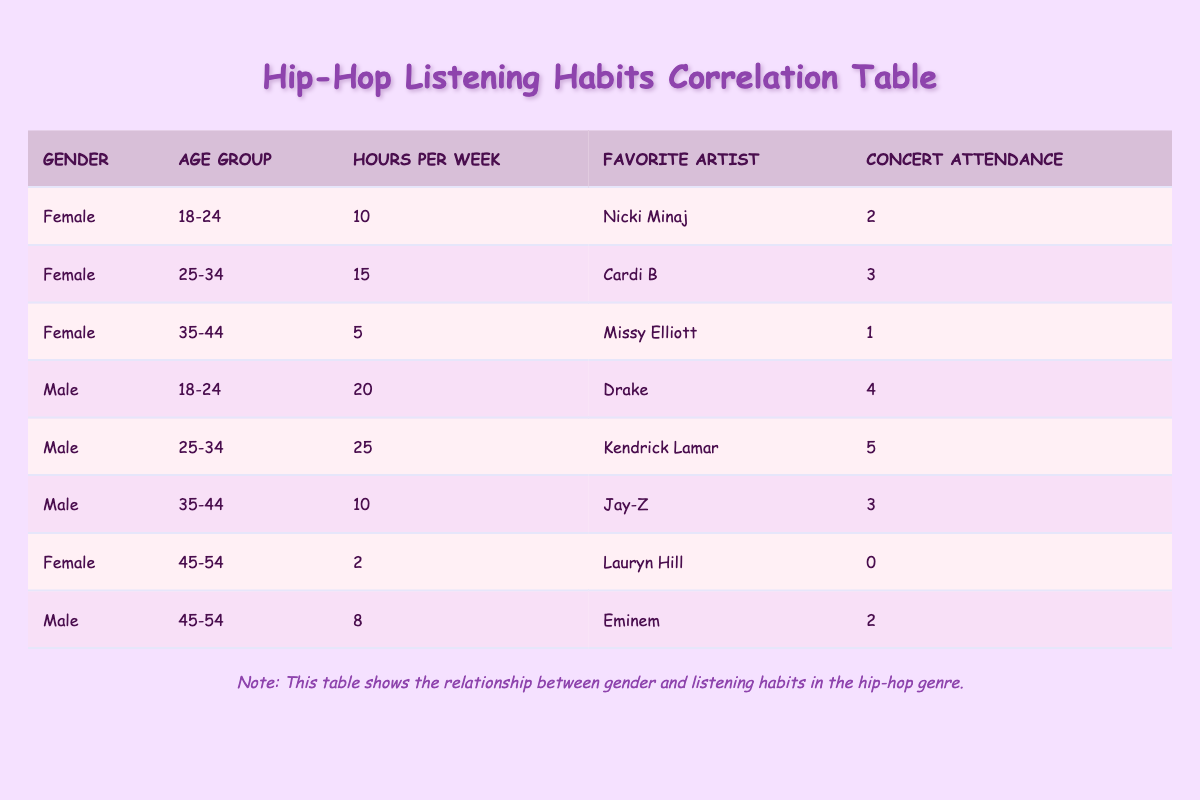What is the favorite artist of the female in the age group 18-24? The table shows a row for a female in the age group 18-24, and her favorite artist is listed as Nicki Minaj.
Answer: Nicki Minaj How many hours per week do males aged 25-34 spend listening to hip-hop? The table provides a row for males in the age group 25-34, where it states they listen for 25 hours per week.
Answer: 25 What is the total concert attendance for females? To find the total concert attendance for females, we add the concert attendance of all females: 2 (18-24) + 3 (25-34) + 1 (35-44) + 0 (45-54) = 6.
Answer: 6 Is there any female who has attended more than 2 concerts? We check the concert attendance for females and see that the maximum attendance for females is 3, which is for the age group 25-34. Therefore, the answer is yes.
Answer: Yes Which gender has the highest average hours per week listening to hip-hop? For males, we calculate their average: (20 hours + 25 hours + 10 hours + 8 hours) / 4 = 15.75 hours. For females: (10 hours + 15 hours + 5 hours + 2 hours) / 4 = 8 hours. Since 15.75 hours is greater than 8 hours, males have the highest average.
Answer: Male What is the favorite artist of the oldest female? The oldest female in the data is in the age group 45-54, where her favorite artist is Lauryn Hill.
Answer: Lauryn Hill Did any female in the data have a favorite artist who is also a rapper? Among the listed favorite artists for females, Nicki Minaj and Cardi B are both rappers. Therefore, the answer is yes.
Answer: Yes What is the average concert attendance for males aged 35-44? The table shows that males in the age group 35-44 have concert attendance of 3. Since there is only one male in this age group, his attendance is also the average, which is 3.
Answer: 3 How many more hours per week do males aged 18-24 listen compared to females in the same age group? The male aged 18-24 listens for 20 hours per week, while the female in the same age group listens for 10 hours. The difference is 20 - 10 = 10 hours.
Answer: 10 hours 